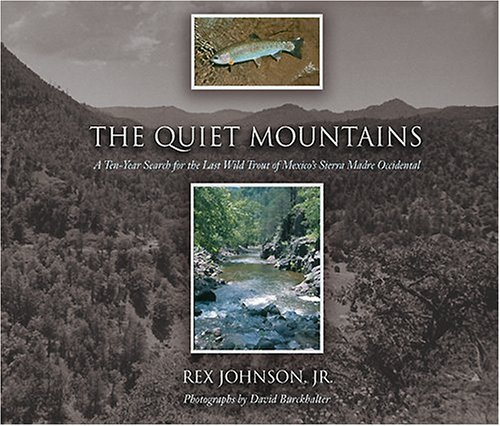What can one expect to learn from this book? Readers can expect to gain insights into the biodiversity of the Sierra Madre Occidental, the challenges of wild trout conservation, and personal anecdotes from the author's decade-long expedition. 